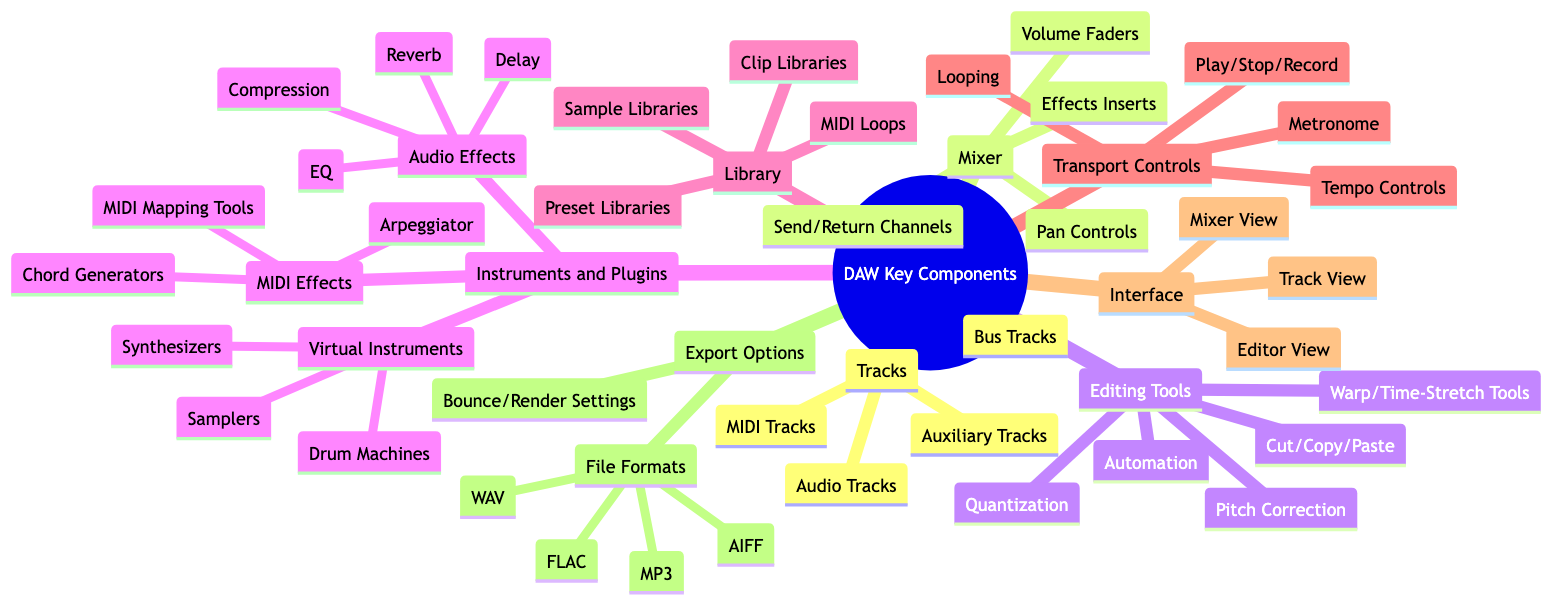What are the types of tracks in a DAW? The diagram lists four specific types of tracks under the "Tracks" component: Audio Tracks, MIDI Tracks, Bus Tracks, and Auxiliary Tracks.
Answer: Audio Tracks, MIDI Tracks, Bus Tracks, Auxiliary Tracks How many editing tools are listed in the Mind Map? The "Editing Tools" branch shows five specific tools: Cut/Copy/Paste, Quantization, Automation, Warp/Time-Stretch Tools, and Pitch Correction. Counting these gives a total of five editing tools.
Answer: 5 What types of virtual instruments are included in the Instruments and Plugins section? Under the "Instruments and Plugins" category, there are three listed types of virtual instruments: Synthesizers, Drum Machines, and Samplers. This can be found by looking directly under the "Virtual Instruments" node.
Answer: Synthesizers, Drum Machines, Samplers What are the export file formats available? In the "Export Options" section, four specific file formats are mentioned: WAV, MP3, FLAC, and AIFF. These formats are listed as children of the "File Formats" node, directly answering the question.
Answer: WAV, MP3, FLAC, AIFF Which section includes effects like Reverb and Compression? The "Instruments and Plugins" section has a sub-category called "Audio Effects," where Reverb and Compression are explicitly listed. This shows where these effects are categorized within the Mind Map.
Answer: Audio Effects What controls are found in the Mixer component? The "Mixer" section includes four components: Volume Faders, Pan Controls, Effects Inserts, and Send/Return Channels. By listing these components, we find what controls are associated with the mixer.
Answer: Volume Faders, Pan Controls, Effects Inserts, Send/Return Channels How many components are listed under the Library section? The "Library" branch contains four components: Sample Libraries, Preset Libraries, MIDI Loops, and Clip Libraries. Counting these reveals that there are four distinct items listed under this section of the Mind Map.
Answer: 4 What is one of the transport controls available? Under the "Transport Controls" section, one of the listed controls is "Play/Stop/Record." This direct reference to the controls found in the diagram provides a clear and concise answer.
Answer: Play/Stop/Record 